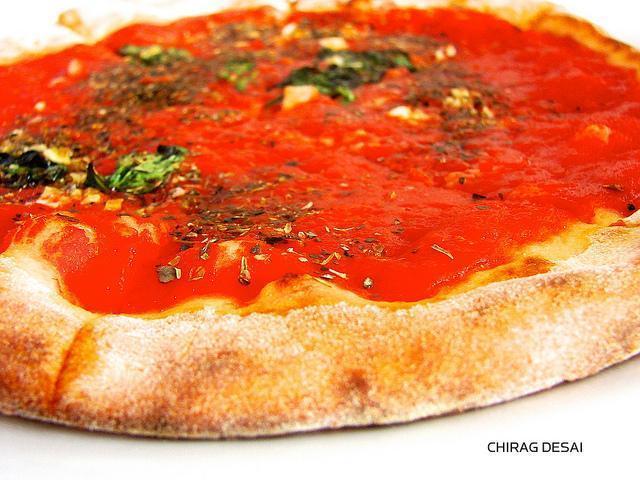How many people are wearing an orange shirt?
Give a very brief answer. 0. 